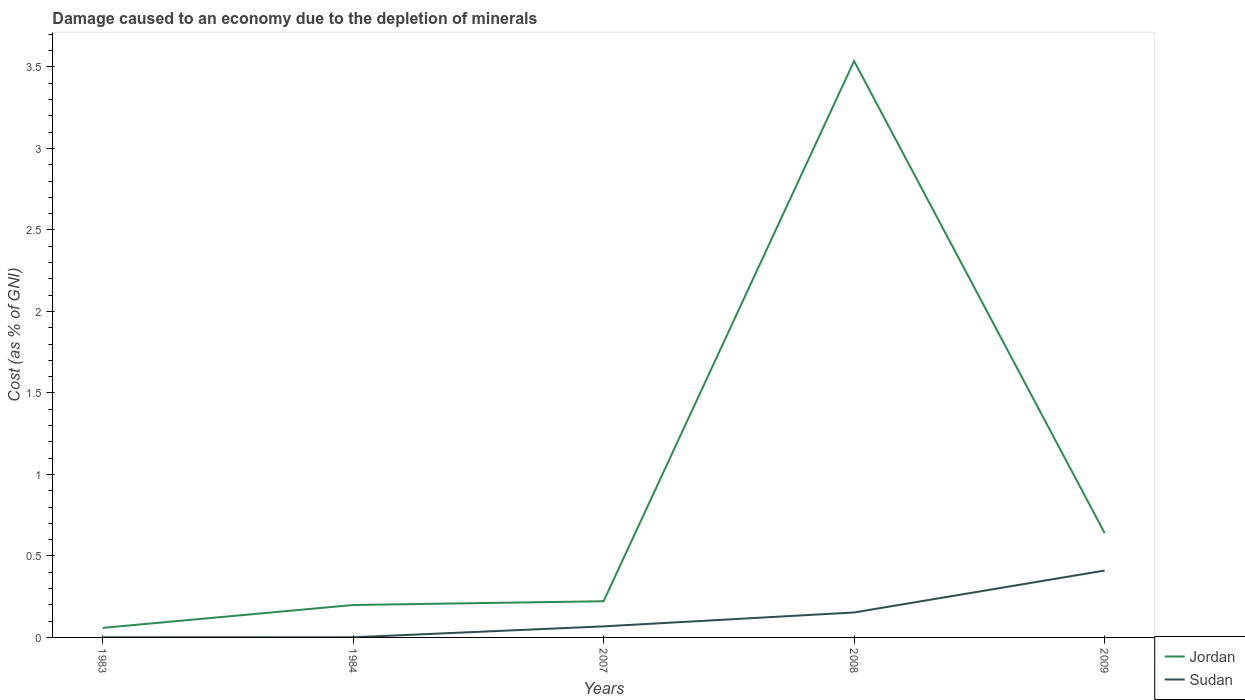Is the number of lines equal to the number of legend labels?
Your answer should be very brief. Yes. Across all years, what is the maximum cost of damage caused due to the depletion of minerals in Sudan?
Your answer should be compact. 0. In which year was the cost of damage caused due to the depletion of minerals in Sudan maximum?
Provide a succinct answer. 1983. What is the total cost of damage caused due to the depletion of minerals in Sudan in the graph?
Your answer should be compact. -0.07. What is the difference between the highest and the second highest cost of damage caused due to the depletion of minerals in Sudan?
Give a very brief answer. 0.41. What is the difference between the highest and the lowest cost of damage caused due to the depletion of minerals in Sudan?
Your answer should be compact. 2. Does the graph contain any zero values?
Provide a succinct answer. No. Does the graph contain grids?
Ensure brevity in your answer.  No. Where does the legend appear in the graph?
Keep it short and to the point. Bottom right. What is the title of the graph?
Your response must be concise. Damage caused to an economy due to the depletion of minerals. Does "France" appear as one of the legend labels in the graph?
Your answer should be very brief. No. What is the label or title of the Y-axis?
Offer a terse response. Cost (as % of GNI). What is the Cost (as % of GNI) in Jordan in 1983?
Offer a terse response. 0.06. What is the Cost (as % of GNI) in Sudan in 1983?
Your response must be concise. 0. What is the Cost (as % of GNI) of Jordan in 1984?
Make the answer very short. 0.2. What is the Cost (as % of GNI) of Sudan in 1984?
Offer a very short reply. 0. What is the Cost (as % of GNI) in Jordan in 2007?
Offer a terse response. 0.22. What is the Cost (as % of GNI) in Sudan in 2007?
Ensure brevity in your answer.  0.07. What is the Cost (as % of GNI) in Jordan in 2008?
Your response must be concise. 3.54. What is the Cost (as % of GNI) in Sudan in 2008?
Make the answer very short. 0.15. What is the Cost (as % of GNI) of Jordan in 2009?
Provide a short and direct response. 0.64. What is the Cost (as % of GNI) in Sudan in 2009?
Provide a short and direct response. 0.41. Across all years, what is the maximum Cost (as % of GNI) in Jordan?
Keep it short and to the point. 3.54. Across all years, what is the maximum Cost (as % of GNI) of Sudan?
Your answer should be compact. 0.41. Across all years, what is the minimum Cost (as % of GNI) in Jordan?
Give a very brief answer. 0.06. Across all years, what is the minimum Cost (as % of GNI) in Sudan?
Provide a succinct answer. 0. What is the total Cost (as % of GNI) in Jordan in the graph?
Offer a very short reply. 4.66. What is the total Cost (as % of GNI) in Sudan in the graph?
Keep it short and to the point. 0.63. What is the difference between the Cost (as % of GNI) of Jordan in 1983 and that in 1984?
Ensure brevity in your answer.  -0.14. What is the difference between the Cost (as % of GNI) in Sudan in 1983 and that in 1984?
Your answer should be very brief. -0. What is the difference between the Cost (as % of GNI) of Jordan in 1983 and that in 2007?
Ensure brevity in your answer.  -0.16. What is the difference between the Cost (as % of GNI) in Sudan in 1983 and that in 2007?
Your answer should be compact. -0.07. What is the difference between the Cost (as % of GNI) of Jordan in 1983 and that in 2008?
Your answer should be very brief. -3.48. What is the difference between the Cost (as % of GNI) of Sudan in 1983 and that in 2008?
Offer a terse response. -0.15. What is the difference between the Cost (as % of GNI) in Jordan in 1983 and that in 2009?
Your response must be concise. -0.58. What is the difference between the Cost (as % of GNI) of Sudan in 1983 and that in 2009?
Provide a short and direct response. -0.41. What is the difference between the Cost (as % of GNI) of Jordan in 1984 and that in 2007?
Keep it short and to the point. -0.02. What is the difference between the Cost (as % of GNI) of Sudan in 1984 and that in 2007?
Provide a short and direct response. -0.07. What is the difference between the Cost (as % of GNI) in Jordan in 1984 and that in 2008?
Your answer should be very brief. -3.34. What is the difference between the Cost (as % of GNI) in Sudan in 1984 and that in 2008?
Give a very brief answer. -0.15. What is the difference between the Cost (as % of GNI) in Jordan in 1984 and that in 2009?
Your answer should be compact. -0.44. What is the difference between the Cost (as % of GNI) of Sudan in 1984 and that in 2009?
Make the answer very short. -0.41. What is the difference between the Cost (as % of GNI) in Jordan in 2007 and that in 2008?
Ensure brevity in your answer.  -3.31. What is the difference between the Cost (as % of GNI) in Sudan in 2007 and that in 2008?
Provide a succinct answer. -0.09. What is the difference between the Cost (as % of GNI) in Jordan in 2007 and that in 2009?
Offer a very short reply. -0.42. What is the difference between the Cost (as % of GNI) of Sudan in 2007 and that in 2009?
Your response must be concise. -0.34. What is the difference between the Cost (as % of GNI) in Jordan in 2008 and that in 2009?
Make the answer very short. 2.9. What is the difference between the Cost (as % of GNI) of Sudan in 2008 and that in 2009?
Keep it short and to the point. -0.26. What is the difference between the Cost (as % of GNI) of Jordan in 1983 and the Cost (as % of GNI) of Sudan in 1984?
Your answer should be very brief. 0.06. What is the difference between the Cost (as % of GNI) of Jordan in 1983 and the Cost (as % of GNI) of Sudan in 2007?
Offer a very short reply. -0.01. What is the difference between the Cost (as % of GNI) in Jordan in 1983 and the Cost (as % of GNI) in Sudan in 2008?
Ensure brevity in your answer.  -0.09. What is the difference between the Cost (as % of GNI) in Jordan in 1983 and the Cost (as % of GNI) in Sudan in 2009?
Ensure brevity in your answer.  -0.35. What is the difference between the Cost (as % of GNI) in Jordan in 1984 and the Cost (as % of GNI) in Sudan in 2007?
Provide a short and direct response. 0.13. What is the difference between the Cost (as % of GNI) in Jordan in 1984 and the Cost (as % of GNI) in Sudan in 2008?
Offer a very short reply. 0.05. What is the difference between the Cost (as % of GNI) of Jordan in 1984 and the Cost (as % of GNI) of Sudan in 2009?
Offer a very short reply. -0.21. What is the difference between the Cost (as % of GNI) of Jordan in 2007 and the Cost (as % of GNI) of Sudan in 2008?
Offer a very short reply. 0.07. What is the difference between the Cost (as % of GNI) in Jordan in 2007 and the Cost (as % of GNI) in Sudan in 2009?
Give a very brief answer. -0.19. What is the difference between the Cost (as % of GNI) of Jordan in 2008 and the Cost (as % of GNI) of Sudan in 2009?
Offer a terse response. 3.13. What is the average Cost (as % of GNI) in Jordan per year?
Your answer should be compact. 0.93. What is the average Cost (as % of GNI) of Sudan per year?
Keep it short and to the point. 0.13. In the year 1983, what is the difference between the Cost (as % of GNI) of Jordan and Cost (as % of GNI) of Sudan?
Provide a succinct answer. 0.06. In the year 1984, what is the difference between the Cost (as % of GNI) in Jordan and Cost (as % of GNI) in Sudan?
Give a very brief answer. 0.2. In the year 2007, what is the difference between the Cost (as % of GNI) of Jordan and Cost (as % of GNI) of Sudan?
Ensure brevity in your answer.  0.15. In the year 2008, what is the difference between the Cost (as % of GNI) in Jordan and Cost (as % of GNI) in Sudan?
Your answer should be compact. 3.38. In the year 2009, what is the difference between the Cost (as % of GNI) in Jordan and Cost (as % of GNI) in Sudan?
Provide a succinct answer. 0.23. What is the ratio of the Cost (as % of GNI) in Jordan in 1983 to that in 1984?
Your response must be concise. 0.29. What is the ratio of the Cost (as % of GNI) in Sudan in 1983 to that in 1984?
Your response must be concise. 0.57. What is the ratio of the Cost (as % of GNI) in Jordan in 1983 to that in 2007?
Give a very brief answer. 0.26. What is the ratio of the Cost (as % of GNI) of Sudan in 1983 to that in 2007?
Offer a very short reply. 0.01. What is the ratio of the Cost (as % of GNI) of Jordan in 1983 to that in 2008?
Offer a very short reply. 0.02. What is the ratio of the Cost (as % of GNI) of Sudan in 1983 to that in 2008?
Ensure brevity in your answer.  0. What is the ratio of the Cost (as % of GNI) of Jordan in 1983 to that in 2009?
Offer a terse response. 0.09. What is the ratio of the Cost (as % of GNI) of Sudan in 1983 to that in 2009?
Provide a succinct answer. 0. What is the ratio of the Cost (as % of GNI) of Jordan in 1984 to that in 2007?
Provide a short and direct response. 0.9. What is the ratio of the Cost (as % of GNI) in Sudan in 1984 to that in 2007?
Offer a very short reply. 0.01. What is the ratio of the Cost (as % of GNI) in Jordan in 1984 to that in 2008?
Give a very brief answer. 0.06. What is the ratio of the Cost (as % of GNI) in Sudan in 1984 to that in 2008?
Provide a succinct answer. 0.01. What is the ratio of the Cost (as % of GNI) in Jordan in 1984 to that in 2009?
Offer a terse response. 0.31. What is the ratio of the Cost (as % of GNI) of Sudan in 1984 to that in 2009?
Offer a terse response. 0. What is the ratio of the Cost (as % of GNI) in Jordan in 2007 to that in 2008?
Give a very brief answer. 0.06. What is the ratio of the Cost (as % of GNI) in Sudan in 2007 to that in 2008?
Make the answer very short. 0.44. What is the ratio of the Cost (as % of GNI) of Jordan in 2007 to that in 2009?
Your response must be concise. 0.35. What is the ratio of the Cost (as % of GNI) of Sudan in 2007 to that in 2009?
Make the answer very short. 0.17. What is the ratio of the Cost (as % of GNI) of Jordan in 2008 to that in 2009?
Keep it short and to the point. 5.52. What is the ratio of the Cost (as % of GNI) in Sudan in 2008 to that in 2009?
Your answer should be very brief. 0.37. What is the difference between the highest and the second highest Cost (as % of GNI) of Jordan?
Provide a succinct answer. 2.9. What is the difference between the highest and the second highest Cost (as % of GNI) in Sudan?
Keep it short and to the point. 0.26. What is the difference between the highest and the lowest Cost (as % of GNI) of Jordan?
Make the answer very short. 3.48. What is the difference between the highest and the lowest Cost (as % of GNI) in Sudan?
Keep it short and to the point. 0.41. 